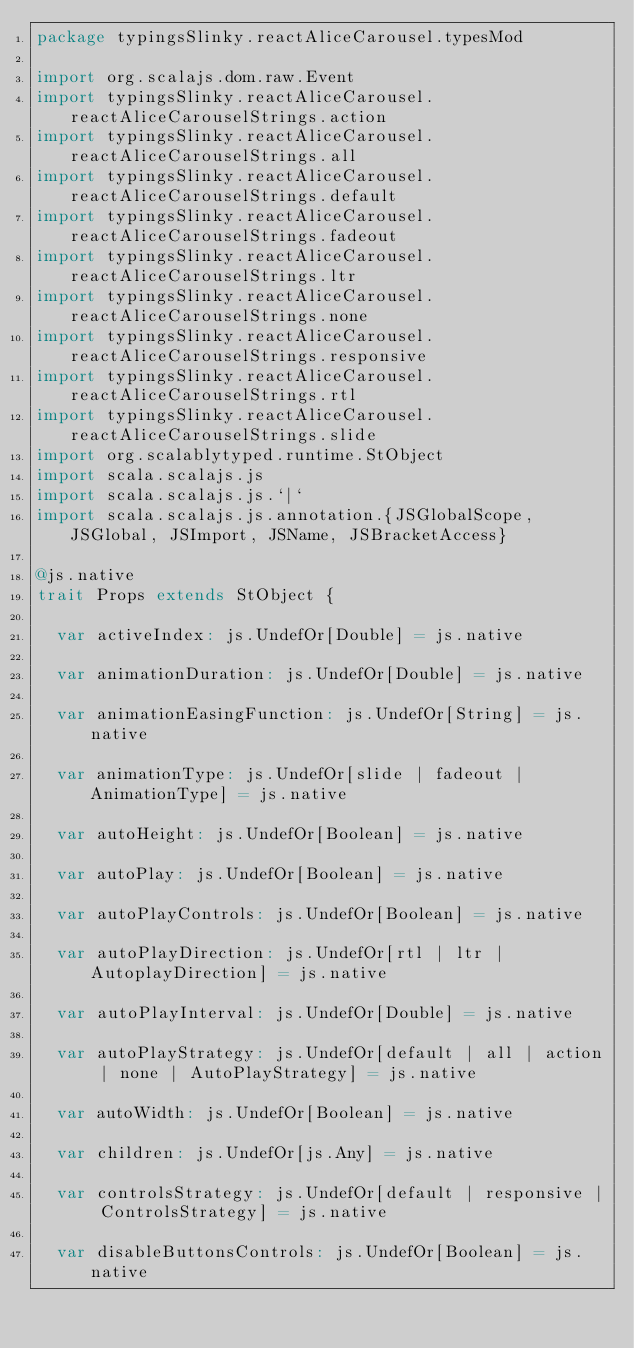<code> <loc_0><loc_0><loc_500><loc_500><_Scala_>package typingsSlinky.reactAliceCarousel.typesMod

import org.scalajs.dom.raw.Event
import typingsSlinky.reactAliceCarousel.reactAliceCarouselStrings.action
import typingsSlinky.reactAliceCarousel.reactAliceCarouselStrings.all
import typingsSlinky.reactAliceCarousel.reactAliceCarouselStrings.default
import typingsSlinky.reactAliceCarousel.reactAliceCarouselStrings.fadeout
import typingsSlinky.reactAliceCarousel.reactAliceCarouselStrings.ltr
import typingsSlinky.reactAliceCarousel.reactAliceCarouselStrings.none
import typingsSlinky.reactAliceCarousel.reactAliceCarouselStrings.responsive
import typingsSlinky.reactAliceCarousel.reactAliceCarouselStrings.rtl
import typingsSlinky.reactAliceCarousel.reactAliceCarouselStrings.slide
import org.scalablytyped.runtime.StObject
import scala.scalajs.js
import scala.scalajs.js.`|`
import scala.scalajs.js.annotation.{JSGlobalScope, JSGlobal, JSImport, JSName, JSBracketAccess}

@js.native
trait Props extends StObject {
  
  var activeIndex: js.UndefOr[Double] = js.native
  
  var animationDuration: js.UndefOr[Double] = js.native
  
  var animationEasingFunction: js.UndefOr[String] = js.native
  
  var animationType: js.UndefOr[slide | fadeout | AnimationType] = js.native
  
  var autoHeight: js.UndefOr[Boolean] = js.native
  
  var autoPlay: js.UndefOr[Boolean] = js.native
  
  var autoPlayControls: js.UndefOr[Boolean] = js.native
  
  var autoPlayDirection: js.UndefOr[rtl | ltr | AutoplayDirection] = js.native
  
  var autoPlayInterval: js.UndefOr[Double] = js.native
  
  var autoPlayStrategy: js.UndefOr[default | all | action | none | AutoPlayStrategy] = js.native
  
  var autoWidth: js.UndefOr[Boolean] = js.native
  
  var children: js.UndefOr[js.Any] = js.native
  
  var controlsStrategy: js.UndefOr[default | responsive | ControlsStrategy] = js.native
  
  var disableButtonsControls: js.UndefOr[Boolean] = js.native
  </code> 